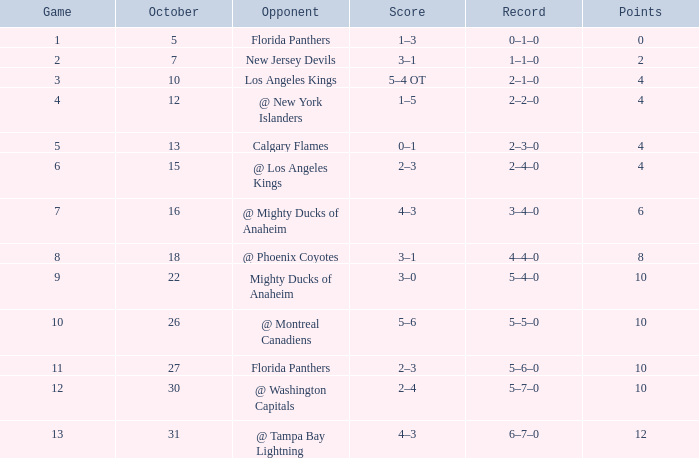Can you identify the team with a score of 2? 3–1. 